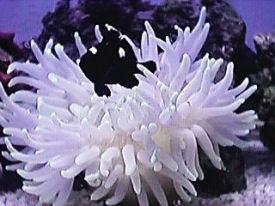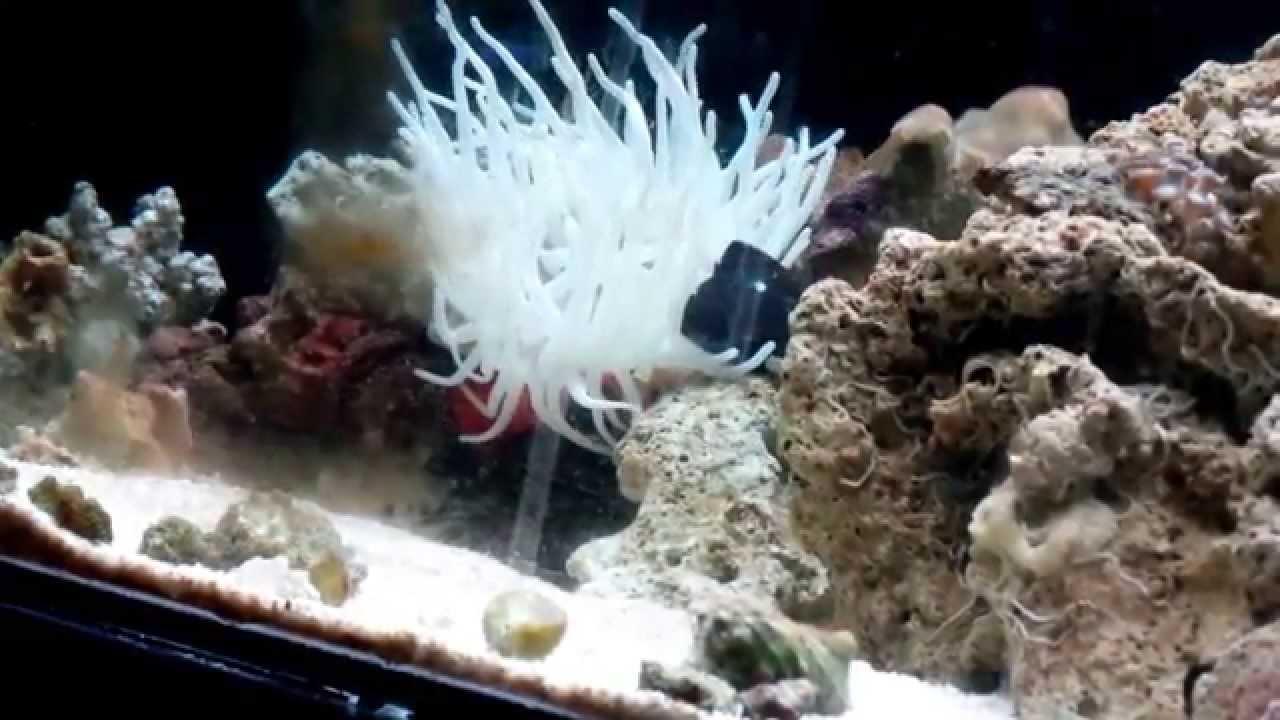The first image is the image on the left, the second image is the image on the right. Evaluate the accuracy of this statement regarding the images: "The left and right image contains the same number of fish.". Is it true? Answer yes or no. Yes. The first image is the image on the left, the second image is the image on the right. Given the left and right images, does the statement "At least one fish is orange." hold true? Answer yes or no. No. 